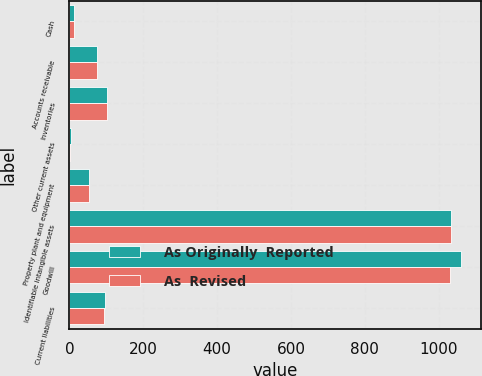Convert chart. <chart><loc_0><loc_0><loc_500><loc_500><stacked_bar_chart><ecel><fcel>Cash<fcel>Accounts receivable<fcel>Inventories<fcel>Other current assets<fcel>Property plant and equipment<fcel>Identifiable intangible assets<fcel>Goodwill<fcel>Current liabilities<nl><fcel>As Originally  Reported<fcel>11.8<fcel>75.9<fcel>102.4<fcel>2.9<fcel>53.4<fcel>1033.8<fcel>1061.9<fcel>97.2<nl><fcel>As  Revised<fcel>11.8<fcel>75.9<fcel>101.8<fcel>2.8<fcel>53.1<fcel>1033.8<fcel>1031<fcel>94.7<nl></chart> 